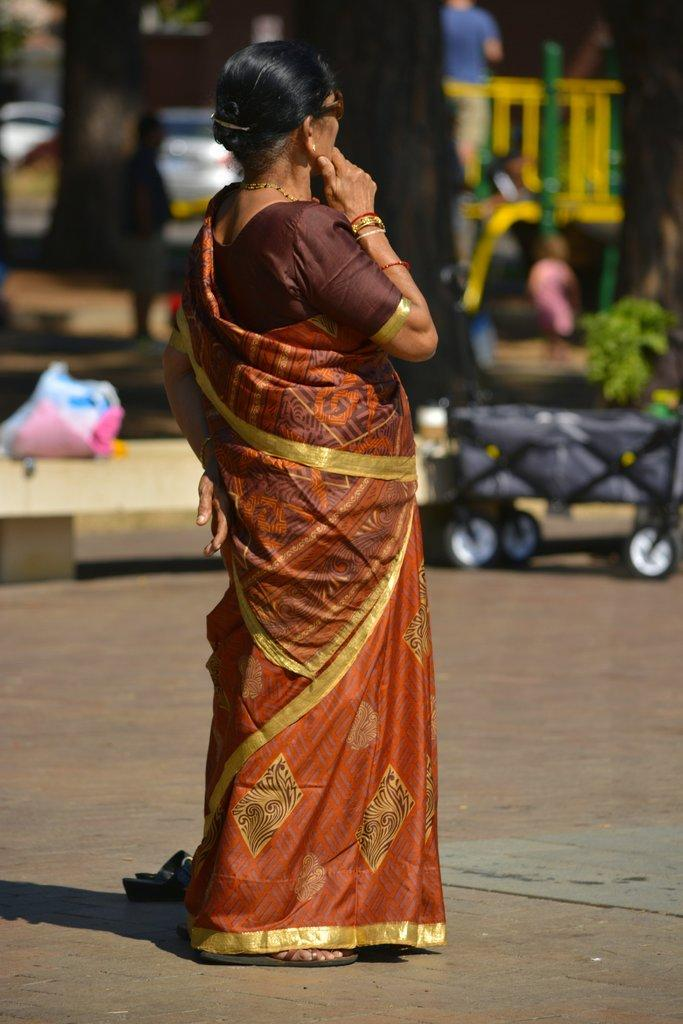What is the woman in the image wearing? The woman is wearing a saree, bangles, a neck chain, and goggles. What type of footwear is the woman wearing? The facts provided do not mention the woman's footwear. What can be seen in the background of the image? The background of the image is blurred. What is the woman standing on in the image? The woman is standing on a footpath. What other objects or structures are present in the image? There is a plant, a fence, and a vehicle in the image. What type of scarf is the boy wearing in the image? There is no boy present in the image, and therefore no scarf can be observed. How many pages are visible in the image? There are no pages present in the image. 